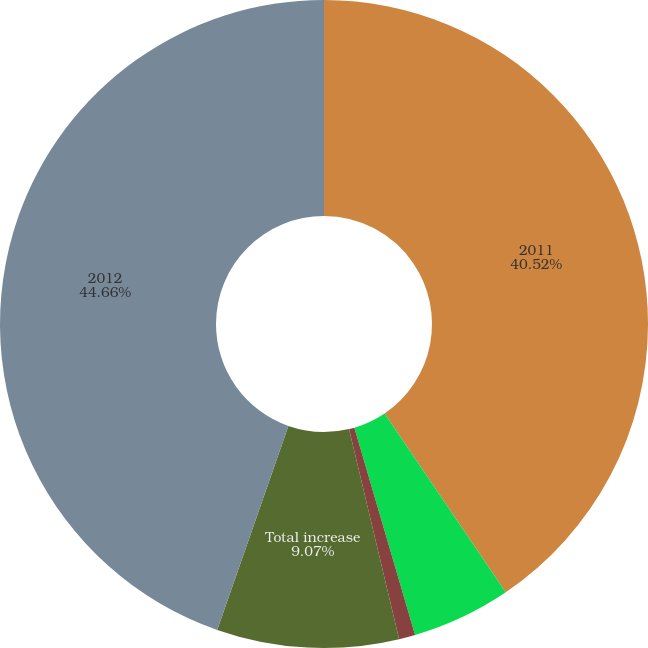Convert chart to OTSL. <chart><loc_0><loc_0><loc_500><loc_500><pie_chart><fcel>2011<fcel>Truck delivery volume<fcel>Currency translation<fcel>Total increase<fcel>2012<nl><fcel>40.52%<fcel>4.94%<fcel>0.81%<fcel>9.07%<fcel>44.65%<nl></chart> 